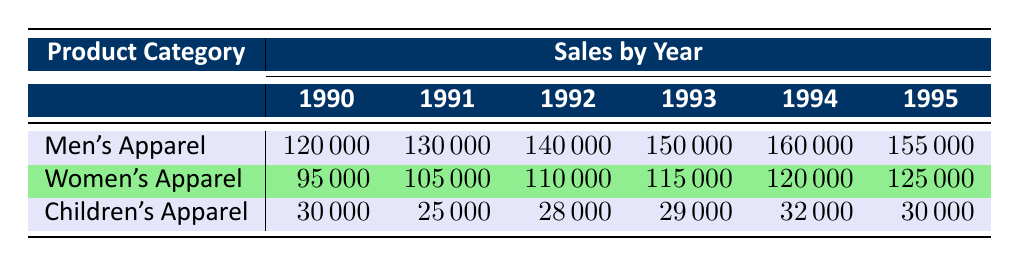What was the total sales for Women's Apparel in 1992? From the table, the sales for Women's Apparel in 1992 is listed as 110000.
Answer: 110000 Which product category had the highest sales in 1993? In the year 1993, Men's Apparel had sales of 150000, compared to Women's Apparel with 115000 and Children's Apparel with 29000. Therefore, Men's Apparel had the highest sales.
Answer: Men's Apparel What is the difference in sales between Men's Apparel and Children's Apparel in 1994? In 1994, Men's Apparel sales were 160000, and Children's Apparel sales were 32000. Subtracting the children's sales from men's: 160000 - 32000 = 128000.
Answer: 128000 Did Women's Apparel sales increase every year from 1990 to 1995? Looking at the sales figures, Women's Apparel sales increased from 95000 in 1990 to 125000 in 1995, showing consistent growth each year.
Answer: Yes What was the average sales for Children's Apparel over the years? The sales data for Children's Apparel from 1990 to 1995 are 30000, 25000, 28000, 29000, and 32000. Adding these gives 30000 + 25000 + 28000 + 29000 + 32000 = 144000. Dividing by 6 (the number of years) gives an average of 144000 / 6 = 24000.
Answer: 24000 Which year showed the largest increase in sales for Men's Apparel? Reviewing the sales figures, Men's Apparel sales increased from 120000 in 1990 to 160000 in 1994. The largest increase occurred between 1993 (150000) and 1994 (160000), which is a difference of 10000. Therefore, the largest increase is from 1993 to 1994.
Answer: 1993 to 1994 How much did total sales for all categories in 1995 compare to 1990? In 1995, total sales were 155000 (Men's) + 125000 (Women's) + 30000 (Children's) = 310000. For 1990, total sales were 120000 (Men's) + 95000 (Women's) + 30000 (Children's) = 245000. Comparing these totals, 310000 - 245000 = 65000, indicating an increase of 65000.
Answer: 65000 